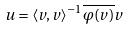<formula> <loc_0><loc_0><loc_500><loc_500>u = \langle v , v \rangle ^ { - 1 } \overline { \varphi ( v ) } v</formula> 